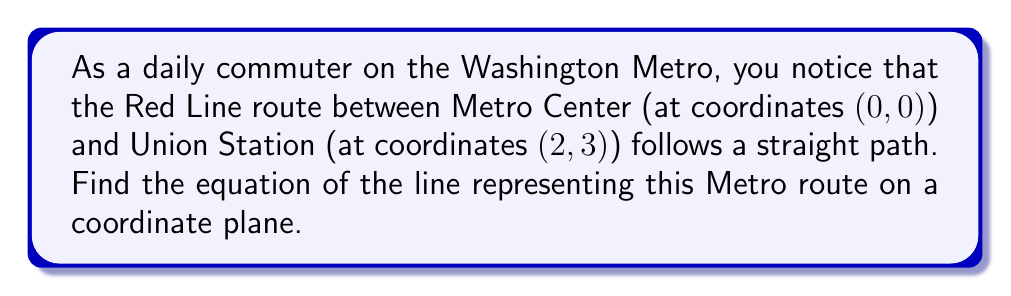Show me your answer to this math problem. To find the equation of a line, we can use the point-slope form and then convert it to slope-intercept form. Let's approach this step-by-step:

1. Identify the two points:
   Point 1 (Metro Center): $(x_1, y_1) = (0, 0)$
   Point 2 (Union Station): $(x_2, y_2) = (2, 3)$

2. Calculate the slope $(m)$ using the slope formula:
   $$m = \frac{y_2 - y_1}{x_2 - x_1} = \frac{3 - 0}{2 - 0} = \frac{3}{2}$$

3. Use the point-slope form of a line with $(x_1, y_1) = (0, 0)$:
   $$y - y_1 = m(x - x_1)$$
   $$y - 0 = \frac{3}{2}(x - 0)$$

4. Simplify:
   $$y = \frac{3}{2}x$$

5. This is already in slope-intercept form $(y = mx + b)$, where $m = \frac{3}{2}$ and $b = 0$.

Therefore, the equation of the line representing the Red Line route between Metro Center and Union Station is $y = \frac{3}{2}x$.

[asy]
import graph;
size(200);
xaxis("x", arrow=Arrow);
yaxis("y", arrow=Arrow);
dot((0,0));
dot((2,3));
draw((0,0)--(2,3), red+1);
label("Metro Center (0,0)", (0,0), SW);
label("Union Station (2,3)", (2,3), NE);
label("Red Line", (1,1.5), SE, red);
[/asy]
Answer: $y = \frac{3}{2}x$ 